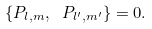Convert formula to latex. <formula><loc_0><loc_0><loc_500><loc_500>\{ P _ { l , m } , \ P _ { l ^ { \prime } , m ^ { \prime } } \} = 0 .</formula> 